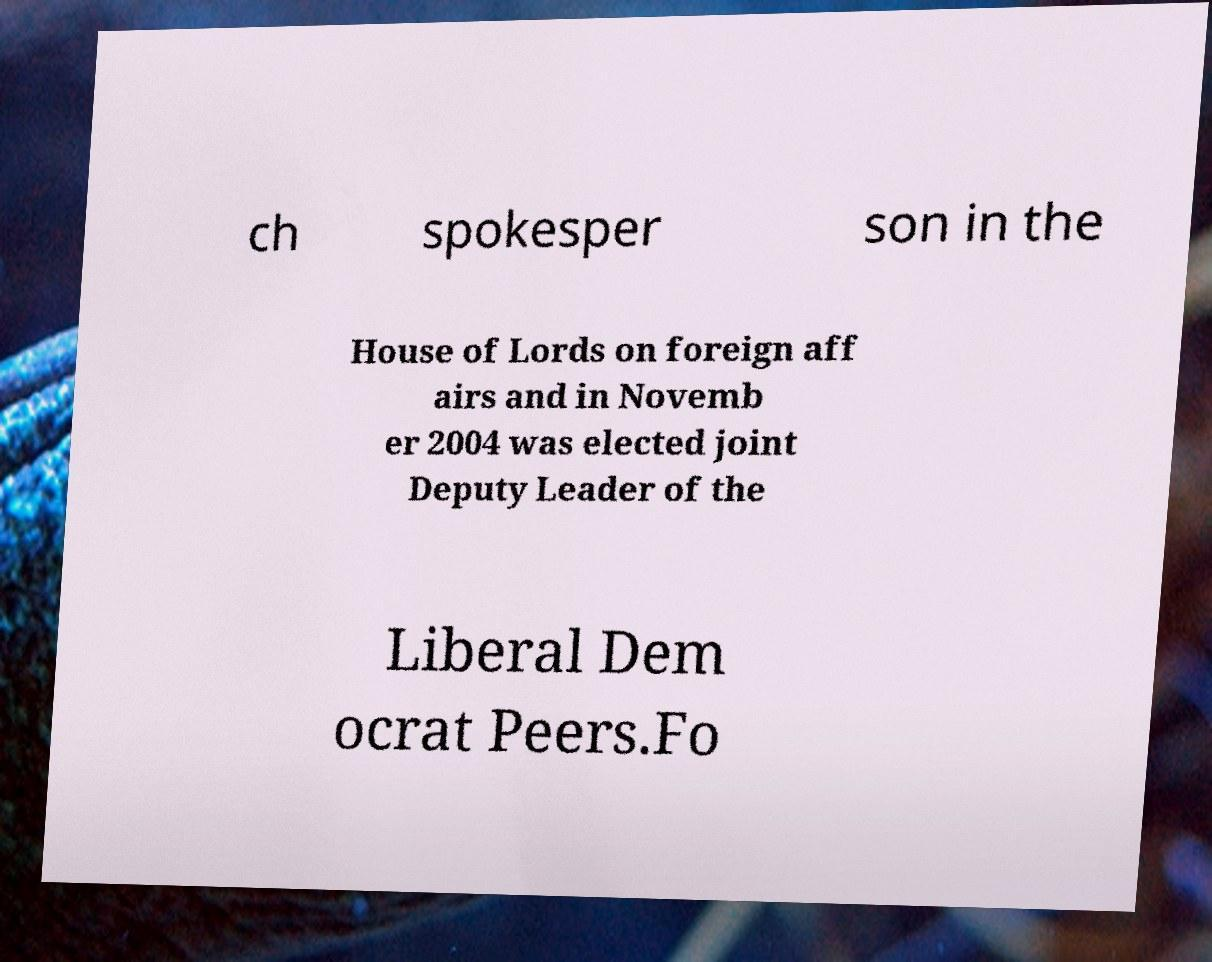Could you assist in decoding the text presented in this image and type it out clearly? ch spokesper son in the House of Lords on foreign aff airs and in Novemb er 2004 was elected joint Deputy Leader of the Liberal Dem ocrat Peers.Fo 